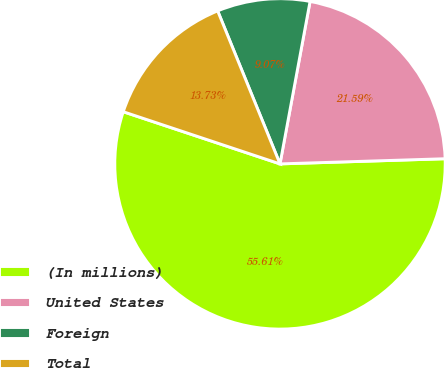<chart> <loc_0><loc_0><loc_500><loc_500><pie_chart><fcel>(In millions)<fcel>United States<fcel>Foreign<fcel>Total<nl><fcel>55.61%<fcel>21.59%<fcel>9.07%<fcel>13.73%<nl></chart> 